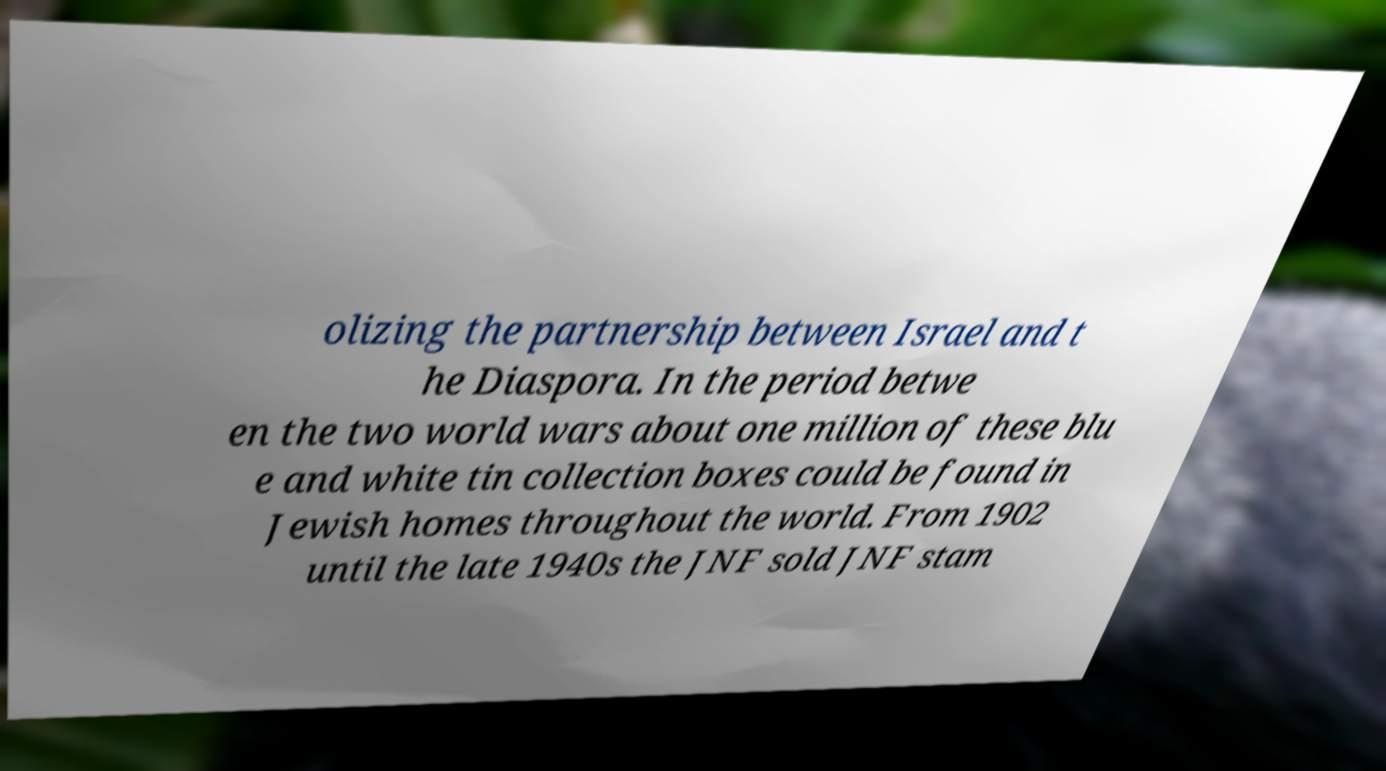What messages or text are displayed in this image? I need them in a readable, typed format. olizing the partnership between Israel and t he Diaspora. In the period betwe en the two world wars about one million of these blu e and white tin collection boxes could be found in Jewish homes throughout the world. From 1902 until the late 1940s the JNF sold JNF stam 